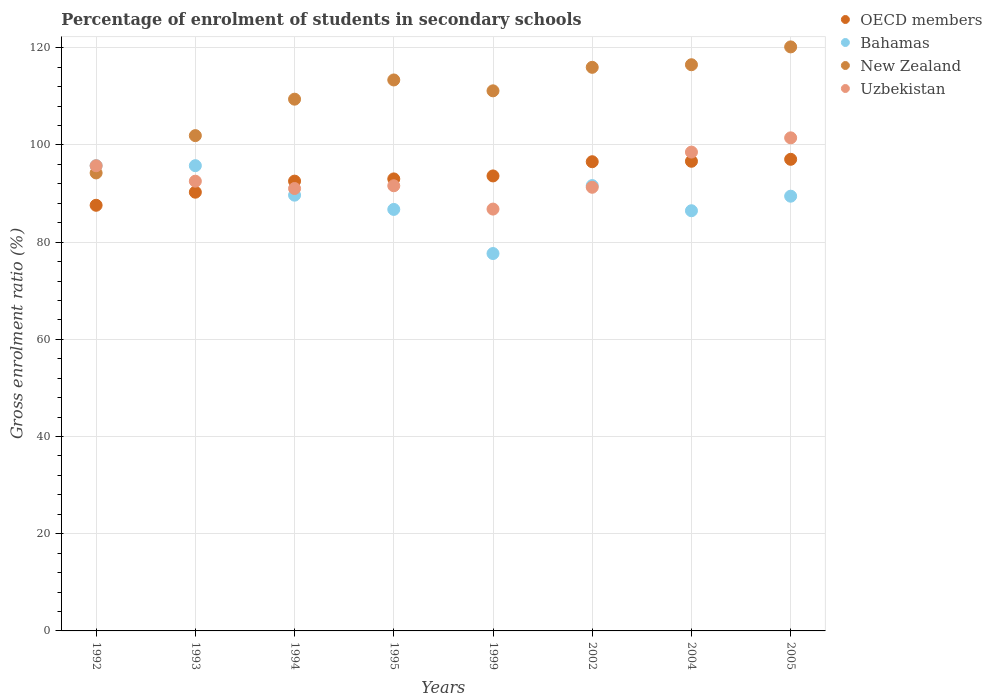How many different coloured dotlines are there?
Keep it short and to the point. 4. Is the number of dotlines equal to the number of legend labels?
Ensure brevity in your answer.  Yes. What is the percentage of students enrolled in secondary schools in OECD members in 2005?
Ensure brevity in your answer.  97.05. Across all years, what is the maximum percentage of students enrolled in secondary schools in Bahamas?
Offer a very short reply. 95.74. Across all years, what is the minimum percentage of students enrolled in secondary schools in Bahamas?
Provide a short and direct response. 77.66. What is the total percentage of students enrolled in secondary schools in Bahamas in the graph?
Keep it short and to the point. 713.09. What is the difference between the percentage of students enrolled in secondary schools in Uzbekistan in 1994 and that in 1999?
Your answer should be compact. 4.23. What is the difference between the percentage of students enrolled in secondary schools in New Zealand in 2004 and the percentage of students enrolled in secondary schools in Uzbekistan in 1994?
Keep it short and to the point. 25.47. What is the average percentage of students enrolled in secondary schools in Uzbekistan per year?
Your answer should be very brief. 93.62. In the year 1994, what is the difference between the percentage of students enrolled in secondary schools in Uzbekistan and percentage of students enrolled in secondary schools in Bahamas?
Provide a succinct answer. 1.37. In how many years, is the percentage of students enrolled in secondary schools in New Zealand greater than 4 %?
Your answer should be very brief. 8. What is the ratio of the percentage of students enrolled in secondary schools in Bahamas in 1994 to that in 1999?
Provide a succinct answer. 1.15. What is the difference between the highest and the second highest percentage of students enrolled in secondary schools in Uzbekistan?
Give a very brief answer. 2.93. What is the difference between the highest and the lowest percentage of students enrolled in secondary schools in Uzbekistan?
Your answer should be compact. 14.66. Is it the case that in every year, the sum of the percentage of students enrolled in secondary schools in Bahamas and percentage of students enrolled in secondary schools in New Zealand  is greater than the percentage of students enrolled in secondary schools in OECD members?
Your response must be concise. Yes. Does the percentage of students enrolled in secondary schools in OECD members monotonically increase over the years?
Your answer should be very brief. Yes. Is the percentage of students enrolled in secondary schools in Uzbekistan strictly greater than the percentage of students enrolled in secondary schools in Bahamas over the years?
Give a very brief answer. No. Is the percentage of students enrolled in secondary schools in OECD members strictly less than the percentage of students enrolled in secondary schools in Bahamas over the years?
Provide a short and direct response. No. How many dotlines are there?
Your answer should be very brief. 4. What is the difference between two consecutive major ticks on the Y-axis?
Make the answer very short. 20. Are the values on the major ticks of Y-axis written in scientific E-notation?
Your answer should be very brief. No. Does the graph contain any zero values?
Your answer should be compact. No. How are the legend labels stacked?
Your answer should be compact. Vertical. What is the title of the graph?
Offer a terse response. Percentage of enrolment of students in secondary schools. What is the label or title of the Y-axis?
Your answer should be compact. Gross enrolment ratio (%). What is the Gross enrolment ratio (%) of OECD members in 1992?
Ensure brevity in your answer.  87.59. What is the Gross enrolment ratio (%) of Bahamas in 1992?
Your answer should be compact. 95.73. What is the Gross enrolment ratio (%) of New Zealand in 1992?
Provide a succinct answer. 94.24. What is the Gross enrolment ratio (%) of Uzbekistan in 1992?
Offer a terse response. 95.72. What is the Gross enrolment ratio (%) in OECD members in 1993?
Ensure brevity in your answer.  90.28. What is the Gross enrolment ratio (%) in Bahamas in 1993?
Your response must be concise. 95.74. What is the Gross enrolment ratio (%) in New Zealand in 1993?
Provide a succinct answer. 101.92. What is the Gross enrolment ratio (%) of Uzbekistan in 1993?
Offer a terse response. 92.54. What is the Gross enrolment ratio (%) of OECD members in 1994?
Offer a terse response. 92.56. What is the Gross enrolment ratio (%) in Bahamas in 1994?
Provide a succinct answer. 89.67. What is the Gross enrolment ratio (%) in New Zealand in 1994?
Keep it short and to the point. 109.42. What is the Gross enrolment ratio (%) in Uzbekistan in 1994?
Offer a terse response. 91.03. What is the Gross enrolment ratio (%) of OECD members in 1995?
Ensure brevity in your answer.  93.01. What is the Gross enrolment ratio (%) in Bahamas in 1995?
Ensure brevity in your answer.  86.73. What is the Gross enrolment ratio (%) in New Zealand in 1995?
Your response must be concise. 113.37. What is the Gross enrolment ratio (%) of Uzbekistan in 1995?
Ensure brevity in your answer.  91.6. What is the Gross enrolment ratio (%) of OECD members in 1999?
Your answer should be very brief. 93.62. What is the Gross enrolment ratio (%) in Bahamas in 1999?
Provide a short and direct response. 77.66. What is the Gross enrolment ratio (%) in New Zealand in 1999?
Ensure brevity in your answer.  111.14. What is the Gross enrolment ratio (%) of Uzbekistan in 1999?
Ensure brevity in your answer.  86.8. What is the Gross enrolment ratio (%) of OECD members in 2002?
Ensure brevity in your answer.  96.55. What is the Gross enrolment ratio (%) in Bahamas in 2002?
Make the answer very short. 91.64. What is the Gross enrolment ratio (%) in New Zealand in 2002?
Offer a terse response. 115.97. What is the Gross enrolment ratio (%) in Uzbekistan in 2002?
Provide a short and direct response. 91.29. What is the Gross enrolment ratio (%) of OECD members in 2004?
Make the answer very short. 96.64. What is the Gross enrolment ratio (%) of Bahamas in 2004?
Make the answer very short. 86.46. What is the Gross enrolment ratio (%) of New Zealand in 2004?
Your answer should be very brief. 116.51. What is the Gross enrolment ratio (%) in Uzbekistan in 2004?
Give a very brief answer. 98.53. What is the Gross enrolment ratio (%) in OECD members in 2005?
Keep it short and to the point. 97.05. What is the Gross enrolment ratio (%) of Bahamas in 2005?
Your answer should be very brief. 89.46. What is the Gross enrolment ratio (%) of New Zealand in 2005?
Offer a very short reply. 120.18. What is the Gross enrolment ratio (%) in Uzbekistan in 2005?
Give a very brief answer. 101.46. Across all years, what is the maximum Gross enrolment ratio (%) of OECD members?
Your response must be concise. 97.05. Across all years, what is the maximum Gross enrolment ratio (%) in Bahamas?
Give a very brief answer. 95.74. Across all years, what is the maximum Gross enrolment ratio (%) in New Zealand?
Ensure brevity in your answer.  120.18. Across all years, what is the maximum Gross enrolment ratio (%) in Uzbekistan?
Provide a succinct answer. 101.46. Across all years, what is the minimum Gross enrolment ratio (%) in OECD members?
Your response must be concise. 87.59. Across all years, what is the minimum Gross enrolment ratio (%) in Bahamas?
Your answer should be very brief. 77.66. Across all years, what is the minimum Gross enrolment ratio (%) in New Zealand?
Provide a short and direct response. 94.24. Across all years, what is the minimum Gross enrolment ratio (%) of Uzbekistan?
Provide a short and direct response. 86.8. What is the total Gross enrolment ratio (%) of OECD members in the graph?
Give a very brief answer. 747.29. What is the total Gross enrolment ratio (%) in Bahamas in the graph?
Provide a short and direct response. 713.09. What is the total Gross enrolment ratio (%) in New Zealand in the graph?
Your response must be concise. 882.75. What is the total Gross enrolment ratio (%) of Uzbekistan in the graph?
Ensure brevity in your answer.  748.99. What is the difference between the Gross enrolment ratio (%) of OECD members in 1992 and that in 1993?
Provide a short and direct response. -2.69. What is the difference between the Gross enrolment ratio (%) of Bahamas in 1992 and that in 1993?
Provide a succinct answer. -0. What is the difference between the Gross enrolment ratio (%) of New Zealand in 1992 and that in 1993?
Your answer should be compact. -7.68. What is the difference between the Gross enrolment ratio (%) of Uzbekistan in 1992 and that in 1993?
Make the answer very short. 3.18. What is the difference between the Gross enrolment ratio (%) of OECD members in 1992 and that in 1994?
Ensure brevity in your answer.  -4.97. What is the difference between the Gross enrolment ratio (%) of Bahamas in 1992 and that in 1994?
Offer a very short reply. 6.07. What is the difference between the Gross enrolment ratio (%) in New Zealand in 1992 and that in 1994?
Ensure brevity in your answer.  -15.18. What is the difference between the Gross enrolment ratio (%) in Uzbekistan in 1992 and that in 1994?
Ensure brevity in your answer.  4.69. What is the difference between the Gross enrolment ratio (%) in OECD members in 1992 and that in 1995?
Your response must be concise. -5.43. What is the difference between the Gross enrolment ratio (%) of Bahamas in 1992 and that in 1995?
Offer a very short reply. 9. What is the difference between the Gross enrolment ratio (%) in New Zealand in 1992 and that in 1995?
Offer a very short reply. -19.13. What is the difference between the Gross enrolment ratio (%) of Uzbekistan in 1992 and that in 1995?
Give a very brief answer. 4.12. What is the difference between the Gross enrolment ratio (%) of OECD members in 1992 and that in 1999?
Provide a short and direct response. -6.04. What is the difference between the Gross enrolment ratio (%) of Bahamas in 1992 and that in 1999?
Offer a terse response. 18.08. What is the difference between the Gross enrolment ratio (%) of New Zealand in 1992 and that in 1999?
Offer a very short reply. -16.89. What is the difference between the Gross enrolment ratio (%) of Uzbekistan in 1992 and that in 1999?
Offer a terse response. 8.92. What is the difference between the Gross enrolment ratio (%) of OECD members in 1992 and that in 2002?
Provide a succinct answer. -8.96. What is the difference between the Gross enrolment ratio (%) of Bahamas in 1992 and that in 2002?
Ensure brevity in your answer.  4.1. What is the difference between the Gross enrolment ratio (%) of New Zealand in 1992 and that in 2002?
Give a very brief answer. -21.73. What is the difference between the Gross enrolment ratio (%) in Uzbekistan in 1992 and that in 2002?
Give a very brief answer. 4.43. What is the difference between the Gross enrolment ratio (%) in OECD members in 1992 and that in 2004?
Ensure brevity in your answer.  -9.05. What is the difference between the Gross enrolment ratio (%) of Bahamas in 1992 and that in 2004?
Your answer should be compact. 9.27. What is the difference between the Gross enrolment ratio (%) in New Zealand in 1992 and that in 2004?
Keep it short and to the point. -22.26. What is the difference between the Gross enrolment ratio (%) of Uzbekistan in 1992 and that in 2004?
Keep it short and to the point. -2.81. What is the difference between the Gross enrolment ratio (%) of OECD members in 1992 and that in 2005?
Provide a short and direct response. -9.46. What is the difference between the Gross enrolment ratio (%) of Bahamas in 1992 and that in 2005?
Provide a short and direct response. 6.28. What is the difference between the Gross enrolment ratio (%) of New Zealand in 1992 and that in 2005?
Offer a terse response. -25.93. What is the difference between the Gross enrolment ratio (%) in Uzbekistan in 1992 and that in 2005?
Make the answer very short. -5.74. What is the difference between the Gross enrolment ratio (%) of OECD members in 1993 and that in 1994?
Give a very brief answer. -2.28. What is the difference between the Gross enrolment ratio (%) in Bahamas in 1993 and that in 1994?
Make the answer very short. 6.07. What is the difference between the Gross enrolment ratio (%) in New Zealand in 1993 and that in 1994?
Make the answer very short. -7.5. What is the difference between the Gross enrolment ratio (%) of Uzbekistan in 1993 and that in 1994?
Offer a terse response. 1.51. What is the difference between the Gross enrolment ratio (%) in OECD members in 1993 and that in 1995?
Provide a short and direct response. -2.73. What is the difference between the Gross enrolment ratio (%) in Bahamas in 1993 and that in 1995?
Make the answer very short. 9. What is the difference between the Gross enrolment ratio (%) of New Zealand in 1993 and that in 1995?
Make the answer very short. -11.45. What is the difference between the Gross enrolment ratio (%) in Uzbekistan in 1993 and that in 1995?
Provide a succinct answer. 0.94. What is the difference between the Gross enrolment ratio (%) in OECD members in 1993 and that in 1999?
Your response must be concise. -3.35. What is the difference between the Gross enrolment ratio (%) of Bahamas in 1993 and that in 1999?
Your answer should be compact. 18.08. What is the difference between the Gross enrolment ratio (%) of New Zealand in 1993 and that in 1999?
Your answer should be compact. -9.22. What is the difference between the Gross enrolment ratio (%) in Uzbekistan in 1993 and that in 1999?
Offer a terse response. 5.74. What is the difference between the Gross enrolment ratio (%) of OECD members in 1993 and that in 2002?
Offer a terse response. -6.27. What is the difference between the Gross enrolment ratio (%) in Bahamas in 1993 and that in 2002?
Offer a terse response. 4.1. What is the difference between the Gross enrolment ratio (%) in New Zealand in 1993 and that in 2002?
Provide a short and direct response. -14.05. What is the difference between the Gross enrolment ratio (%) in Uzbekistan in 1993 and that in 2002?
Your answer should be compact. 1.25. What is the difference between the Gross enrolment ratio (%) in OECD members in 1993 and that in 2004?
Give a very brief answer. -6.36. What is the difference between the Gross enrolment ratio (%) in Bahamas in 1993 and that in 2004?
Give a very brief answer. 9.27. What is the difference between the Gross enrolment ratio (%) of New Zealand in 1993 and that in 2004?
Offer a terse response. -14.59. What is the difference between the Gross enrolment ratio (%) of Uzbekistan in 1993 and that in 2004?
Offer a very short reply. -5.99. What is the difference between the Gross enrolment ratio (%) in OECD members in 1993 and that in 2005?
Your response must be concise. -6.77. What is the difference between the Gross enrolment ratio (%) in Bahamas in 1993 and that in 2005?
Your response must be concise. 6.28. What is the difference between the Gross enrolment ratio (%) of New Zealand in 1993 and that in 2005?
Give a very brief answer. -18.26. What is the difference between the Gross enrolment ratio (%) in Uzbekistan in 1993 and that in 2005?
Provide a short and direct response. -8.92. What is the difference between the Gross enrolment ratio (%) of OECD members in 1994 and that in 1995?
Your answer should be compact. -0.46. What is the difference between the Gross enrolment ratio (%) in Bahamas in 1994 and that in 1995?
Offer a terse response. 2.93. What is the difference between the Gross enrolment ratio (%) in New Zealand in 1994 and that in 1995?
Offer a very short reply. -3.95. What is the difference between the Gross enrolment ratio (%) in Uzbekistan in 1994 and that in 1995?
Offer a terse response. -0.57. What is the difference between the Gross enrolment ratio (%) of OECD members in 1994 and that in 1999?
Provide a succinct answer. -1.07. What is the difference between the Gross enrolment ratio (%) of Bahamas in 1994 and that in 1999?
Provide a short and direct response. 12.01. What is the difference between the Gross enrolment ratio (%) of New Zealand in 1994 and that in 1999?
Offer a terse response. -1.72. What is the difference between the Gross enrolment ratio (%) in Uzbekistan in 1994 and that in 1999?
Ensure brevity in your answer.  4.23. What is the difference between the Gross enrolment ratio (%) in OECD members in 1994 and that in 2002?
Provide a short and direct response. -3.99. What is the difference between the Gross enrolment ratio (%) of Bahamas in 1994 and that in 2002?
Provide a succinct answer. -1.97. What is the difference between the Gross enrolment ratio (%) in New Zealand in 1994 and that in 2002?
Keep it short and to the point. -6.55. What is the difference between the Gross enrolment ratio (%) of Uzbekistan in 1994 and that in 2002?
Make the answer very short. -0.26. What is the difference between the Gross enrolment ratio (%) in OECD members in 1994 and that in 2004?
Ensure brevity in your answer.  -4.08. What is the difference between the Gross enrolment ratio (%) in Bahamas in 1994 and that in 2004?
Give a very brief answer. 3.2. What is the difference between the Gross enrolment ratio (%) of New Zealand in 1994 and that in 2004?
Make the answer very short. -7.08. What is the difference between the Gross enrolment ratio (%) in Uzbekistan in 1994 and that in 2004?
Your answer should be compact. -7.5. What is the difference between the Gross enrolment ratio (%) of OECD members in 1994 and that in 2005?
Give a very brief answer. -4.49. What is the difference between the Gross enrolment ratio (%) of Bahamas in 1994 and that in 2005?
Offer a very short reply. 0.21. What is the difference between the Gross enrolment ratio (%) in New Zealand in 1994 and that in 2005?
Offer a very short reply. -10.76. What is the difference between the Gross enrolment ratio (%) in Uzbekistan in 1994 and that in 2005?
Your answer should be very brief. -10.43. What is the difference between the Gross enrolment ratio (%) in OECD members in 1995 and that in 1999?
Your answer should be compact. -0.61. What is the difference between the Gross enrolment ratio (%) in Bahamas in 1995 and that in 1999?
Give a very brief answer. 9.08. What is the difference between the Gross enrolment ratio (%) in New Zealand in 1995 and that in 1999?
Provide a short and direct response. 2.24. What is the difference between the Gross enrolment ratio (%) of Uzbekistan in 1995 and that in 1999?
Provide a succinct answer. 4.8. What is the difference between the Gross enrolment ratio (%) of OECD members in 1995 and that in 2002?
Provide a succinct answer. -3.54. What is the difference between the Gross enrolment ratio (%) in Bahamas in 1995 and that in 2002?
Ensure brevity in your answer.  -4.9. What is the difference between the Gross enrolment ratio (%) in New Zealand in 1995 and that in 2002?
Ensure brevity in your answer.  -2.6. What is the difference between the Gross enrolment ratio (%) of Uzbekistan in 1995 and that in 2002?
Make the answer very short. 0.31. What is the difference between the Gross enrolment ratio (%) in OECD members in 1995 and that in 2004?
Offer a very short reply. -3.63. What is the difference between the Gross enrolment ratio (%) of Bahamas in 1995 and that in 2004?
Offer a terse response. 0.27. What is the difference between the Gross enrolment ratio (%) in New Zealand in 1995 and that in 2004?
Give a very brief answer. -3.13. What is the difference between the Gross enrolment ratio (%) of Uzbekistan in 1995 and that in 2004?
Provide a short and direct response. -6.93. What is the difference between the Gross enrolment ratio (%) in OECD members in 1995 and that in 2005?
Your answer should be compact. -4.03. What is the difference between the Gross enrolment ratio (%) in Bahamas in 1995 and that in 2005?
Your answer should be very brief. -2.72. What is the difference between the Gross enrolment ratio (%) in New Zealand in 1995 and that in 2005?
Your answer should be very brief. -6.8. What is the difference between the Gross enrolment ratio (%) of Uzbekistan in 1995 and that in 2005?
Make the answer very short. -9.86. What is the difference between the Gross enrolment ratio (%) of OECD members in 1999 and that in 2002?
Your answer should be compact. -2.93. What is the difference between the Gross enrolment ratio (%) in Bahamas in 1999 and that in 2002?
Your answer should be very brief. -13.98. What is the difference between the Gross enrolment ratio (%) in New Zealand in 1999 and that in 2002?
Provide a succinct answer. -4.84. What is the difference between the Gross enrolment ratio (%) in Uzbekistan in 1999 and that in 2002?
Your answer should be compact. -4.49. What is the difference between the Gross enrolment ratio (%) of OECD members in 1999 and that in 2004?
Make the answer very short. -3.02. What is the difference between the Gross enrolment ratio (%) in Bahamas in 1999 and that in 2004?
Provide a succinct answer. -8.81. What is the difference between the Gross enrolment ratio (%) of New Zealand in 1999 and that in 2004?
Provide a succinct answer. -5.37. What is the difference between the Gross enrolment ratio (%) in Uzbekistan in 1999 and that in 2004?
Offer a terse response. -11.73. What is the difference between the Gross enrolment ratio (%) of OECD members in 1999 and that in 2005?
Make the answer very short. -3.42. What is the difference between the Gross enrolment ratio (%) in Bahamas in 1999 and that in 2005?
Offer a terse response. -11.8. What is the difference between the Gross enrolment ratio (%) in New Zealand in 1999 and that in 2005?
Your response must be concise. -9.04. What is the difference between the Gross enrolment ratio (%) in Uzbekistan in 1999 and that in 2005?
Ensure brevity in your answer.  -14.66. What is the difference between the Gross enrolment ratio (%) in OECD members in 2002 and that in 2004?
Keep it short and to the point. -0.09. What is the difference between the Gross enrolment ratio (%) in Bahamas in 2002 and that in 2004?
Offer a very short reply. 5.17. What is the difference between the Gross enrolment ratio (%) in New Zealand in 2002 and that in 2004?
Your answer should be very brief. -0.53. What is the difference between the Gross enrolment ratio (%) in Uzbekistan in 2002 and that in 2004?
Ensure brevity in your answer.  -7.24. What is the difference between the Gross enrolment ratio (%) of OECD members in 2002 and that in 2005?
Offer a terse response. -0.5. What is the difference between the Gross enrolment ratio (%) of Bahamas in 2002 and that in 2005?
Give a very brief answer. 2.18. What is the difference between the Gross enrolment ratio (%) in New Zealand in 2002 and that in 2005?
Your answer should be very brief. -4.2. What is the difference between the Gross enrolment ratio (%) of Uzbekistan in 2002 and that in 2005?
Provide a short and direct response. -10.17. What is the difference between the Gross enrolment ratio (%) of OECD members in 2004 and that in 2005?
Give a very brief answer. -0.41. What is the difference between the Gross enrolment ratio (%) in Bahamas in 2004 and that in 2005?
Provide a short and direct response. -2.99. What is the difference between the Gross enrolment ratio (%) of New Zealand in 2004 and that in 2005?
Your answer should be compact. -3.67. What is the difference between the Gross enrolment ratio (%) of Uzbekistan in 2004 and that in 2005?
Offer a terse response. -2.93. What is the difference between the Gross enrolment ratio (%) of OECD members in 1992 and the Gross enrolment ratio (%) of Bahamas in 1993?
Give a very brief answer. -8.15. What is the difference between the Gross enrolment ratio (%) in OECD members in 1992 and the Gross enrolment ratio (%) in New Zealand in 1993?
Your answer should be compact. -14.33. What is the difference between the Gross enrolment ratio (%) of OECD members in 1992 and the Gross enrolment ratio (%) of Uzbekistan in 1993?
Offer a very short reply. -4.95. What is the difference between the Gross enrolment ratio (%) of Bahamas in 1992 and the Gross enrolment ratio (%) of New Zealand in 1993?
Make the answer very short. -6.19. What is the difference between the Gross enrolment ratio (%) in Bahamas in 1992 and the Gross enrolment ratio (%) in Uzbekistan in 1993?
Offer a terse response. 3.19. What is the difference between the Gross enrolment ratio (%) of New Zealand in 1992 and the Gross enrolment ratio (%) of Uzbekistan in 1993?
Your response must be concise. 1.7. What is the difference between the Gross enrolment ratio (%) in OECD members in 1992 and the Gross enrolment ratio (%) in Bahamas in 1994?
Your answer should be very brief. -2.08. What is the difference between the Gross enrolment ratio (%) of OECD members in 1992 and the Gross enrolment ratio (%) of New Zealand in 1994?
Give a very brief answer. -21.83. What is the difference between the Gross enrolment ratio (%) in OECD members in 1992 and the Gross enrolment ratio (%) in Uzbekistan in 1994?
Offer a very short reply. -3.45. What is the difference between the Gross enrolment ratio (%) in Bahamas in 1992 and the Gross enrolment ratio (%) in New Zealand in 1994?
Provide a succinct answer. -13.69. What is the difference between the Gross enrolment ratio (%) of Bahamas in 1992 and the Gross enrolment ratio (%) of Uzbekistan in 1994?
Make the answer very short. 4.7. What is the difference between the Gross enrolment ratio (%) of New Zealand in 1992 and the Gross enrolment ratio (%) of Uzbekistan in 1994?
Your response must be concise. 3.21. What is the difference between the Gross enrolment ratio (%) of OECD members in 1992 and the Gross enrolment ratio (%) of Bahamas in 1995?
Your answer should be very brief. 0.85. What is the difference between the Gross enrolment ratio (%) in OECD members in 1992 and the Gross enrolment ratio (%) in New Zealand in 1995?
Your answer should be compact. -25.79. What is the difference between the Gross enrolment ratio (%) in OECD members in 1992 and the Gross enrolment ratio (%) in Uzbekistan in 1995?
Your answer should be compact. -4.02. What is the difference between the Gross enrolment ratio (%) in Bahamas in 1992 and the Gross enrolment ratio (%) in New Zealand in 1995?
Your response must be concise. -17.64. What is the difference between the Gross enrolment ratio (%) of Bahamas in 1992 and the Gross enrolment ratio (%) of Uzbekistan in 1995?
Your answer should be compact. 4.13. What is the difference between the Gross enrolment ratio (%) in New Zealand in 1992 and the Gross enrolment ratio (%) in Uzbekistan in 1995?
Your answer should be very brief. 2.64. What is the difference between the Gross enrolment ratio (%) of OECD members in 1992 and the Gross enrolment ratio (%) of Bahamas in 1999?
Your answer should be compact. 9.93. What is the difference between the Gross enrolment ratio (%) in OECD members in 1992 and the Gross enrolment ratio (%) in New Zealand in 1999?
Your answer should be very brief. -23.55. What is the difference between the Gross enrolment ratio (%) in OECD members in 1992 and the Gross enrolment ratio (%) in Uzbekistan in 1999?
Make the answer very short. 0.78. What is the difference between the Gross enrolment ratio (%) of Bahamas in 1992 and the Gross enrolment ratio (%) of New Zealand in 1999?
Offer a very short reply. -15.4. What is the difference between the Gross enrolment ratio (%) in Bahamas in 1992 and the Gross enrolment ratio (%) in Uzbekistan in 1999?
Offer a terse response. 8.93. What is the difference between the Gross enrolment ratio (%) in New Zealand in 1992 and the Gross enrolment ratio (%) in Uzbekistan in 1999?
Offer a terse response. 7.44. What is the difference between the Gross enrolment ratio (%) in OECD members in 1992 and the Gross enrolment ratio (%) in Bahamas in 2002?
Offer a very short reply. -4.05. What is the difference between the Gross enrolment ratio (%) of OECD members in 1992 and the Gross enrolment ratio (%) of New Zealand in 2002?
Your answer should be very brief. -28.39. What is the difference between the Gross enrolment ratio (%) in OECD members in 1992 and the Gross enrolment ratio (%) in Uzbekistan in 2002?
Offer a terse response. -3.71. What is the difference between the Gross enrolment ratio (%) of Bahamas in 1992 and the Gross enrolment ratio (%) of New Zealand in 2002?
Keep it short and to the point. -20.24. What is the difference between the Gross enrolment ratio (%) in Bahamas in 1992 and the Gross enrolment ratio (%) in Uzbekistan in 2002?
Your answer should be compact. 4.44. What is the difference between the Gross enrolment ratio (%) in New Zealand in 1992 and the Gross enrolment ratio (%) in Uzbekistan in 2002?
Give a very brief answer. 2.95. What is the difference between the Gross enrolment ratio (%) in OECD members in 1992 and the Gross enrolment ratio (%) in Bahamas in 2004?
Offer a very short reply. 1.12. What is the difference between the Gross enrolment ratio (%) of OECD members in 1992 and the Gross enrolment ratio (%) of New Zealand in 2004?
Your answer should be very brief. -28.92. What is the difference between the Gross enrolment ratio (%) in OECD members in 1992 and the Gross enrolment ratio (%) in Uzbekistan in 2004?
Provide a short and direct response. -10.94. What is the difference between the Gross enrolment ratio (%) in Bahamas in 1992 and the Gross enrolment ratio (%) in New Zealand in 2004?
Make the answer very short. -20.77. What is the difference between the Gross enrolment ratio (%) in Bahamas in 1992 and the Gross enrolment ratio (%) in Uzbekistan in 2004?
Offer a very short reply. -2.8. What is the difference between the Gross enrolment ratio (%) of New Zealand in 1992 and the Gross enrolment ratio (%) of Uzbekistan in 2004?
Provide a succinct answer. -4.29. What is the difference between the Gross enrolment ratio (%) in OECD members in 1992 and the Gross enrolment ratio (%) in Bahamas in 2005?
Make the answer very short. -1.87. What is the difference between the Gross enrolment ratio (%) in OECD members in 1992 and the Gross enrolment ratio (%) in New Zealand in 2005?
Provide a short and direct response. -32.59. What is the difference between the Gross enrolment ratio (%) of OECD members in 1992 and the Gross enrolment ratio (%) of Uzbekistan in 2005?
Keep it short and to the point. -13.88. What is the difference between the Gross enrolment ratio (%) in Bahamas in 1992 and the Gross enrolment ratio (%) in New Zealand in 2005?
Provide a succinct answer. -24.44. What is the difference between the Gross enrolment ratio (%) of Bahamas in 1992 and the Gross enrolment ratio (%) of Uzbekistan in 2005?
Give a very brief answer. -5.73. What is the difference between the Gross enrolment ratio (%) in New Zealand in 1992 and the Gross enrolment ratio (%) in Uzbekistan in 2005?
Your answer should be compact. -7.22. What is the difference between the Gross enrolment ratio (%) in OECD members in 1993 and the Gross enrolment ratio (%) in Bahamas in 1994?
Make the answer very short. 0.61. What is the difference between the Gross enrolment ratio (%) of OECD members in 1993 and the Gross enrolment ratio (%) of New Zealand in 1994?
Your response must be concise. -19.14. What is the difference between the Gross enrolment ratio (%) of OECD members in 1993 and the Gross enrolment ratio (%) of Uzbekistan in 1994?
Your response must be concise. -0.76. What is the difference between the Gross enrolment ratio (%) in Bahamas in 1993 and the Gross enrolment ratio (%) in New Zealand in 1994?
Offer a terse response. -13.68. What is the difference between the Gross enrolment ratio (%) in Bahamas in 1993 and the Gross enrolment ratio (%) in Uzbekistan in 1994?
Offer a very short reply. 4.7. What is the difference between the Gross enrolment ratio (%) in New Zealand in 1993 and the Gross enrolment ratio (%) in Uzbekistan in 1994?
Make the answer very short. 10.89. What is the difference between the Gross enrolment ratio (%) of OECD members in 1993 and the Gross enrolment ratio (%) of Bahamas in 1995?
Your response must be concise. 3.54. What is the difference between the Gross enrolment ratio (%) of OECD members in 1993 and the Gross enrolment ratio (%) of New Zealand in 1995?
Make the answer very short. -23.1. What is the difference between the Gross enrolment ratio (%) of OECD members in 1993 and the Gross enrolment ratio (%) of Uzbekistan in 1995?
Ensure brevity in your answer.  -1.32. What is the difference between the Gross enrolment ratio (%) in Bahamas in 1993 and the Gross enrolment ratio (%) in New Zealand in 1995?
Provide a succinct answer. -17.64. What is the difference between the Gross enrolment ratio (%) in Bahamas in 1993 and the Gross enrolment ratio (%) in Uzbekistan in 1995?
Make the answer very short. 4.13. What is the difference between the Gross enrolment ratio (%) of New Zealand in 1993 and the Gross enrolment ratio (%) of Uzbekistan in 1995?
Make the answer very short. 10.32. What is the difference between the Gross enrolment ratio (%) of OECD members in 1993 and the Gross enrolment ratio (%) of Bahamas in 1999?
Provide a succinct answer. 12.62. What is the difference between the Gross enrolment ratio (%) of OECD members in 1993 and the Gross enrolment ratio (%) of New Zealand in 1999?
Your answer should be compact. -20.86. What is the difference between the Gross enrolment ratio (%) of OECD members in 1993 and the Gross enrolment ratio (%) of Uzbekistan in 1999?
Offer a terse response. 3.48. What is the difference between the Gross enrolment ratio (%) in Bahamas in 1993 and the Gross enrolment ratio (%) in New Zealand in 1999?
Ensure brevity in your answer.  -15.4. What is the difference between the Gross enrolment ratio (%) in Bahamas in 1993 and the Gross enrolment ratio (%) in Uzbekistan in 1999?
Ensure brevity in your answer.  8.93. What is the difference between the Gross enrolment ratio (%) in New Zealand in 1993 and the Gross enrolment ratio (%) in Uzbekistan in 1999?
Offer a terse response. 15.12. What is the difference between the Gross enrolment ratio (%) in OECD members in 1993 and the Gross enrolment ratio (%) in Bahamas in 2002?
Your response must be concise. -1.36. What is the difference between the Gross enrolment ratio (%) of OECD members in 1993 and the Gross enrolment ratio (%) of New Zealand in 2002?
Your response must be concise. -25.7. What is the difference between the Gross enrolment ratio (%) of OECD members in 1993 and the Gross enrolment ratio (%) of Uzbekistan in 2002?
Provide a short and direct response. -1.01. What is the difference between the Gross enrolment ratio (%) of Bahamas in 1993 and the Gross enrolment ratio (%) of New Zealand in 2002?
Offer a very short reply. -20.24. What is the difference between the Gross enrolment ratio (%) of Bahamas in 1993 and the Gross enrolment ratio (%) of Uzbekistan in 2002?
Your answer should be compact. 4.44. What is the difference between the Gross enrolment ratio (%) in New Zealand in 1993 and the Gross enrolment ratio (%) in Uzbekistan in 2002?
Ensure brevity in your answer.  10.63. What is the difference between the Gross enrolment ratio (%) of OECD members in 1993 and the Gross enrolment ratio (%) of Bahamas in 2004?
Provide a succinct answer. 3.82. What is the difference between the Gross enrolment ratio (%) of OECD members in 1993 and the Gross enrolment ratio (%) of New Zealand in 2004?
Offer a terse response. -26.23. What is the difference between the Gross enrolment ratio (%) of OECD members in 1993 and the Gross enrolment ratio (%) of Uzbekistan in 2004?
Make the answer very short. -8.25. What is the difference between the Gross enrolment ratio (%) in Bahamas in 1993 and the Gross enrolment ratio (%) in New Zealand in 2004?
Offer a very short reply. -20.77. What is the difference between the Gross enrolment ratio (%) in Bahamas in 1993 and the Gross enrolment ratio (%) in Uzbekistan in 2004?
Offer a terse response. -2.79. What is the difference between the Gross enrolment ratio (%) of New Zealand in 1993 and the Gross enrolment ratio (%) of Uzbekistan in 2004?
Offer a very short reply. 3.39. What is the difference between the Gross enrolment ratio (%) in OECD members in 1993 and the Gross enrolment ratio (%) in Bahamas in 2005?
Offer a terse response. 0.82. What is the difference between the Gross enrolment ratio (%) in OECD members in 1993 and the Gross enrolment ratio (%) in New Zealand in 2005?
Provide a succinct answer. -29.9. What is the difference between the Gross enrolment ratio (%) in OECD members in 1993 and the Gross enrolment ratio (%) in Uzbekistan in 2005?
Ensure brevity in your answer.  -11.19. What is the difference between the Gross enrolment ratio (%) in Bahamas in 1993 and the Gross enrolment ratio (%) in New Zealand in 2005?
Your answer should be compact. -24.44. What is the difference between the Gross enrolment ratio (%) in Bahamas in 1993 and the Gross enrolment ratio (%) in Uzbekistan in 2005?
Offer a terse response. -5.73. What is the difference between the Gross enrolment ratio (%) of New Zealand in 1993 and the Gross enrolment ratio (%) of Uzbekistan in 2005?
Your response must be concise. 0.46. What is the difference between the Gross enrolment ratio (%) in OECD members in 1994 and the Gross enrolment ratio (%) in Bahamas in 1995?
Offer a very short reply. 5.82. What is the difference between the Gross enrolment ratio (%) of OECD members in 1994 and the Gross enrolment ratio (%) of New Zealand in 1995?
Your answer should be very brief. -20.82. What is the difference between the Gross enrolment ratio (%) of OECD members in 1994 and the Gross enrolment ratio (%) of Uzbekistan in 1995?
Offer a very short reply. 0.95. What is the difference between the Gross enrolment ratio (%) in Bahamas in 1994 and the Gross enrolment ratio (%) in New Zealand in 1995?
Provide a short and direct response. -23.71. What is the difference between the Gross enrolment ratio (%) of Bahamas in 1994 and the Gross enrolment ratio (%) of Uzbekistan in 1995?
Offer a terse response. -1.94. What is the difference between the Gross enrolment ratio (%) in New Zealand in 1994 and the Gross enrolment ratio (%) in Uzbekistan in 1995?
Offer a very short reply. 17.82. What is the difference between the Gross enrolment ratio (%) of OECD members in 1994 and the Gross enrolment ratio (%) of Bahamas in 1999?
Make the answer very short. 14.9. What is the difference between the Gross enrolment ratio (%) of OECD members in 1994 and the Gross enrolment ratio (%) of New Zealand in 1999?
Your answer should be compact. -18.58. What is the difference between the Gross enrolment ratio (%) in OECD members in 1994 and the Gross enrolment ratio (%) in Uzbekistan in 1999?
Your answer should be compact. 5.75. What is the difference between the Gross enrolment ratio (%) of Bahamas in 1994 and the Gross enrolment ratio (%) of New Zealand in 1999?
Keep it short and to the point. -21.47. What is the difference between the Gross enrolment ratio (%) in Bahamas in 1994 and the Gross enrolment ratio (%) in Uzbekistan in 1999?
Provide a succinct answer. 2.86. What is the difference between the Gross enrolment ratio (%) of New Zealand in 1994 and the Gross enrolment ratio (%) of Uzbekistan in 1999?
Provide a succinct answer. 22.62. What is the difference between the Gross enrolment ratio (%) in OECD members in 1994 and the Gross enrolment ratio (%) in Bahamas in 2002?
Ensure brevity in your answer.  0.92. What is the difference between the Gross enrolment ratio (%) of OECD members in 1994 and the Gross enrolment ratio (%) of New Zealand in 2002?
Provide a succinct answer. -23.42. What is the difference between the Gross enrolment ratio (%) of OECD members in 1994 and the Gross enrolment ratio (%) of Uzbekistan in 2002?
Give a very brief answer. 1.26. What is the difference between the Gross enrolment ratio (%) of Bahamas in 1994 and the Gross enrolment ratio (%) of New Zealand in 2002?
Provide a short and direct response. -26.31. What is the difference between the Gross enrolment ratio (%) in Bahamas in 1994 and the Gross enrolment ratio (%) in Uzbekistan in 2002?
Keep it short and to the point. -1.62. What is the difference between the Gross enrolment ratio (%) in New Zealand in 1994 and the Gross enrolment ratio (%) in Uzbekistan in 2002?
Provide a short and direct response. 18.13. What is the difference between the Gross enrolment ratio (%) of OECD members in 1994 and the Gross enrolment ratio (%) of Bahamas in 2004?
Make the answer very short. 6.09. What is the difference between the Gross enrolment ratio (%) of OECD members in 1994 and the Gross enrolment ratio (%) of New Zealand in 2004?
Offer a very short reply. -23.95. What is the difference between the Gross enrolment ratio (%) in OECD members in 1994 and the Gross enrolment ratio (%) in Uzbekistan in 2004?
Your response must be concise. -5.98. What is the difference between the Gross enrolment ratio (%) of Bahamas in 1994 and the Gross enrolment ratio (%) of New Zealand in 2004?
Make the answer very short. -26.84. What is the difference between the Gross enrolment ratio (%) in Bahamas in 1994 and the Gross enrolment ratio (%) in Uzbekistan in 2004?
Ensure brevity in your answer.  -8.86. What is the difference between the Gross enrolment ratio (%) of New Zealand in 1994 and the Gross enrolment ratio (%) of Uzbekistan in 2004?
Make the answer very short. 10.89. What is the difference between the Gross enrolment ratio (%) of OECD members in 1994 and the Gross enrolment ratio (%) of Bahamas in 2005?
Provide a short and direct response. 3.1. What is the difference between the Gross enrolment ratio (%) of OECD members in 1994 and the Gross enrolment ratio (%) of New Zealand in 2005?
Your answer should be compact. -27.62. What is the difference between the Gross enrolment ratio (%) in OECD members in 1994 and the Gross enrolment ratio (%) in Uzbekistan in 2005?
Keep it short and to the point. -8.91. What is the difference between the Gross enrolment ratio (%) in Bahamas in 1994 and the Gross enrolment ratio (%) in New Zealand in 2005?
Make the answer very short. -30.51. What is the difference between the Gross enrolment ratio (%) of Bahamas in 1994 and the Gross enrolment ratio (%) of Uzbekistan in 2005?
Ensure brevity in your answer.  -11.8. What is the difference between the Gross enrolment ratio (%) of New Zealand in 1994 and the Gross enrolment ratio (%) of Uzbekistan in 2005?
Ensure brevity in your answer.  7.96. What is the difference between the Gross enrolment ratio (%) of OECD members in 1995 and the Gross enrolment ratio (%) of Bahamas in 1999?
Your answer should be very brief. 15.35. What is the difference between the Gross enrolment ratio (%) of OECD members in 1995 and the Gross enrolment ratio (%) of New Zealand in 1999?
Keep it short and to the point. -18.12. What is the difference between the Gross enrolment ratio (%) in OECD members in 1995 and the Gross enrolment ratio (%) in Uzbekistan in 1999?
Ensure brevity in your answer.  6.21. What is the difference between the Gross enrolment ratio (%) of Bahamas in 1995 and the Gross enrolment ratio (%) of New Zealand in 1999?
Your response must be concise. -24.4. What is the difference between the Gross enrolment ratio (%) in Bahamas in 1995 and the Gross enrolment ratio (%) in Uzbekistan in 1999?
Give a very brief answer. -0.07. What is the difference between the Gross enrolment ratio (%) in New Zealand in 1995 and the Gross enrolment ratio (%) in Uzbekistan in 1999?
Provide a succinct answer. 26.57. What is the difference between the Gross enrolment ratio (%) of OECD members in 1995 and the Gross enrolment ratio (%) of Bahamas in 2002?
Provide a short and direct response. 1.37. What is the difference between the Gross enrolment ratio (%) of OECD members in 1995 and the Gross enrolment ratio (%) of New Zealand in 2002?
Make the answer very short. -22.96. What is the difference between the Gross enrolment ratio (%) of OECD members in 1995 and the Gross enrolment ratio (%) of Uzbekistan in 2002?
Your answer should be compact. 1.72. What is the difference between the Gross enrolment ratio (%) in Bahamas in 1995 and the Gross enrolment ratio (%) in New Zealand in 2002?
Provide a succinct answer. -29.24. What is the difference between the Gross enrolment ratio (%) of Bahamas in 1995 and the Gross enrolment ratio (%) of Uzbekistan in 2002?
Give a very brief answer. -4.56. What is the difference between the Gross enrolment ratio (%) in New Zealand in 1995 and the Gross enrolment ratio (%) in Uzbekistan in 2002?
Your response must be concise. 22.08. What is the difference between the Gross enrolment ratio (%) in OECD members in 1995 and the Gross enrolment ratio (%) in Bahamas in 2004?
Offer a terse response. 6.55. What is the difference between the Gross enrolment ratio (%) in OECD members in 1995 and the Gross enrolment ratio (%) in New Zealand in 2004?
Your answer should be compact. -23.49. What is the difference between the Gross enrolment ratio (%) in OECD members in 1995 and the Gross enrolment ratio (%) in Uzbekistan in 2004?
Offer a terse response. -5.52. What is the difference between the Gross enrolment ratio (%) in Bahamas in 1995 and the Gross enrolment ratio (%) in New Zealand in 2004?
Provide a short and direct response. -29.77. What is the difference between the Gross enrolment ratio (%) of Bahamas in 1995 and the Gross enrolment ratio (%) of Uzbekistan in 2004?
Provide a short and direct response. -11.8. What is the difference between the Gross enrolment ratio (%) of New Zealand in 1995 and the Gross enrolment ratio (%) of Uzbekistan in 2004?
Offer a terse response. 14.84. What is the difference between the Gross enrolment ratio (%) of OECD members in 1995 and the Gross enrolment ratio (%) of Bahamas in 2005?
Offer a terse response. 3.56. What is the difference between the Gross enrolment ratio (%) of OECD members in 1995 and the Gross enrolment ratio (%) of New Zealand in 2005?
Provide a succinct answer. -27.16. What is the difference between the Gross enrolment ratio (%) in OECD members in 1995 and the Gross enrolment ratio (%) in Uzbekistan in 2005?
Your response must be concise. -8.45. What is the difference between the Gross enrolment ratio (%) of Bahamas in 1995 and the Gross enrolment ratio (%) of New Zealand in 2005?
Your answer should be very brief. -33.44. What is the difference between the Gross enrolment ratio (%) of Bahamas in 1995 and the Gross enrolment ratio (%) of Uzbekistan in 2005?
Provide a succinct answer. -14.73. What is the difference between the Gross enrolment ratio (%) of New Zealand in 1995 and the Gross enrolment ratio (%) of Uzbekistan in 2005?
Provide a succinct answer. 11.91. What is the difference between the Gross enrolment ratio (%) in OECD members in 1999 and the Gross enrolment ratio (%) in Bahamas in 2002?
Provide a short and direct response. 1.99. What is the difference between the Gross enrolment ratio (%) in OECD members in 1999 and the Gross enrolment ratio (%) in New Zealand in 2002?
Offer a very short reply. -22.35. What is the difference between the Gross enrolment ratio (%) of OECD members in 1999 and the Gross enrolment ratio (%) of Uzbekistan in 2002?
Provide a succinct answer. 2.33. What is the difference between the Gross enrolment ratio (%) of Bahamas in 1999 and the Gross enrolment ratio (%) of New Zealand in 2002?
Offer a terse response. -38.32. What is the difference between the Gross enrolment ratio (%) in Bahamas in 1999 and the Gross enrolment ratio (%) in Uzbekistan in 2002?
Provide a short and direct response. -13.63. What is the difference between the Gross enrolment ratio (%) of New Zealand in 1999 and the Gross enrolment ratio (%) of Uzbekistan in 2002?
Offer a very short reply. 19.85. What is the difference between the Gross enrolment ratio (%) in OECD members in 1999 and the Gross enrolment ratio (%) in Bahamas in 2004?
Give a very brief answer. 7.16. What is the difference between the Gross enrolment ratio (%) in OECD members in 1999 and the Gross enrolment ratio (%) in New Zealand in 2004?
Your answer should be compact. -22.88. What is the difference between the Gross enrolment ratio (%) of OECD members in 1999 and the Gross enrolment ratio (%) of Uzbekistan in 2004?
Provide a succinct answer. -4.91. What is the difference between the Gross enrolment ratio (%) in Bahamas in 1999 and the Gross enrolment ratio (%) in New Zealand in 2004?
Provide a succinct answer. -38.85. What is the difference between the Gross enrolment ratio (%) in Bahamas in 1999 and the Gross enrolment ratio (%) in Uzbekistan in 2004?
Provide a short and direct response. -20.87. What is the difference between the Gross enrolment ratio (%) of New Zealand in 1999 and the Gross enrolment ratio (%) of Uzbekistan in 2004?
Provide a succinct answer. 12.61. What is the difference between the Gross enrolment ratio (%) in OECD members in 1999 and the Gross enrolment ratio (%) in Bahamas in 2005?
Your answer should be compact. 4.17. What is the difference between the Gross enrolment ratio (%) in OECD members in 1999 and the Gross enrolment ratio (%) in New Zealand in 2005?
Give a very brief answer. -26.55. What is the difference between the Gross enrolment ratio (%) in OECD members in 1999 and the Gross enrolment ratio (%) in Uzbekistan in 2005?
Keep it short and to the point. -7.84. What is the difference between the Gross enrolment ratio (%) in Bahamas in 1999 and the Gross enrolment ratio (%) in New Zealand in 2005?
Your answer should be compact. -42.52. What is the difference between the Gross enrolment ratio (%) of Bahamas in 1999 and the Gross enrolment ratio (%) of Uzbekistan in 2005?
Provide a succinct answer. -23.81. What is the difference between the Gross enrolment ratio (%) of New Zealand in 1999 and the Gross enrolment ratio (%) of Uzbekistan in 2005?
Give a very brief answer. 9.67. What is the difference between the Gross enrolment ratio (%) in OECD members in 2002 and the Gross enrolment ratio (%) in Bahamas in 2004?
Provide a succinct answer. 10.09. What is the difference between the Gross enrolment ratio (%) in OECD members in 2002 and the Gross enrolment ratio (%) in New Zealand in 2004?
Offer a very short reply. -19.96. What is the difference between the Gross enrolment ratio (%) in OECD members in 2002 and the Gross enrolment ratio (%) in Uzbekistan in 2004?
Your response must be concise. -1.98. What is the difference between the Gross enrolment ratio (%) of Bahamas in 2002 and the Gross enrolment ratio (%) of New Zealand in 2004?
Make the answer very short. -24.87. What is the difference between the Gross enrolment ratio (%) in Bahamas in 2002 and the Gross enrolment ratio (%) in Uzbekistan in 2004?
Offer a very short reply. -6.89. What is the difference between the Gross enrolment ratio (%) in New Zealand in 2002 and the Gross enrolment ratio (%) in Uzbekistan in 2004?
Make the answer very short. 17.44. What is the difference between the Gross enrolment ratio (%) in OECD members in 2002 and the Gross enrolment ratio (%) in Bahamas in 2005?
Offer a terse response. 7.09. What is the difference between the Gross enrolment ratio (%) of OECD members in 2002 and the Gross enrolment ratio (%) of New Zealand in 2005?
Provide a succinct answer. -23.63. What is the difference between the Gross enrolment ratio (%) in OECD members in 2002 and the Gross enrolment ratio (%) in Uzbekistan in 2005?
Offer a terse response. -4.91. What is the difference between the Gross enrolment ratio (%) in Bahamas in 2002 and the Gross enrolment ratio (%) in New Zealand in 2005?
Provide a short and direct response. -28.54. What is the difference between the Gross enrolment ratio (%) of Bahamas in 2002 and the Gross enrolment ratio (%) of Uzbekistan in 2005?
Keep it short and to the point. -9.83. What is the difference between the Gross enrolment ratio (%) of New Zealand in 2002 and the Gross enrolment ratio (%) of Uzbekistan in 2005?
Your answer should be very brief. 14.51. What is the difference between the Gross enrolment ratio (%) of OECD members in 2004 and the Gross enrolment ratio (%) of Bahamas in 2005?
Offer a terse response. 7.18. What is the difference between the Gross enrolment ratio (%) of OECD members in 2004 and the Gross enrolment ratio (%) of New Zealand in 2005?
Keep it short and to the point. -23.54. What is the difference between the Gross enrolment ratio (%) in OECD members in 2004 and the Gross enrolment ratio (%) in Uzbekistan in 2005?
Provide a short and direct response. -4.82. What is the difference between the Gross enrolment ratio (%) in Bahamas in 2004 and the Gross enrolment ratio (%) in New Zealand in 2005?
Give a very brief answer. -33.71. What is the difference between the Gross enrolment ratio (%) in Bahamas in 2004 and the Gross enrolment ratio (%) in Uzbekistan in 2005?
Ensure brevity in your answer.  -15. What is the difference between the Gross enrolment ratio (%) of New Zealand in 2004 and the Gross enrolment ratio (%) of Uzbekistan in 2005?
Your answer should be very brief. 15.04. What is the average Gross enrolment ratio (%) in OECD members per year?
Make the answer very short. 93.41. What is the average Gross enrolment ratio (%) in Bahamas per year?
Provide a short and direct response. 89.14. What is the average Gross enrolment ratio (%) in New Zealand per year?
Offer a terse response. 110.34. What is the average Gross enrolment ratio (%) of Uzbekistan per year?
Offer a terse response. 93.62. In the year 1992, what is the difference between the Gross enrolment ratio (%) of OECD members and Gross enrolment ratio (%) of Bahamas?
Keep it short and to the point. -8.15. In the year 1992, what is the difference between the Gross enrolment ratio (%) of OECD members and Gross enrolment ratio (%) of New Zealand?
Make the answer very short. -6.66. In the year 1992, what is the difference between the Gross enrolment ratio (%) of OECD members and Gross enrolment ratio (%) of Uzbekistan?
Your response must be concise. -8.13. In the year 1992, what is the difference between the Gross enrolment ratio (%) of Bahamas and Gross enrolment ratio (%) of New Zealand?
Your response must be concise. 1.49. In the year 1992, what is the difference between the Gross enrolment ratio (%) in Bahamas and Gross enrolment ratio (%) in Uzbekistan?
Give a very brief answer. 0.01. In the year 1992, what is the difference between the Gross enrolment ratio (%) in New Zealand and Gross enrolment ratio (%) in Uzbekistan?
Your response must be concise. -1.48. In the year 1993, what is the difference between the Gross enrolment ratio (%) of OECD members and Gross enrolment ratio (%) of Bahamas?
Provide a succinct answer. -5.46. In the year 1993, what is the difference between the Gross enrolment ratio (%) of OECD members and Gross enrolment ratio (%) of New Zealand?
Provide a succinct answer. -11.64. In the year 1993, what is the difference between the Gross enrolment ratio (%) in OECD members and Gross enrolment ratio (%) in Uzbekistan?
Your response must be concise. -2.26. In the year 1993, what is the difference between the Gross enrolment ratio (%) in Bahamas and Gross enrolment ratio (%) in New Zealand?
Offer a very short reply. -6.18. In the year 1993, what is the difference between the Gross enrolment ratio (%) of Bahamas and Gross enrolment ratio (%) of Uzbekistan?
Your answer should be very brief. 3.2. In the year 1993, what is the difference between the Gross enrolment ratio (%) in New Zealand and Gross enrolment ratio (%) in Uzbekistan?
Your answer should be very brief. 9.38. In the year 1994, what is the difference between the Gross enrolment ratio (%) of OECD members and Gross enrolment ratio (%) of Bahamas?
Offer a very short reply. 2.89. In the year 1994, what is the difference between the Gross enrolment ratio (%) of OECD members and Gross enrolment ratio (%) of New Zealand?
Your answer should be compact. -16.86. In the year 1994, what is the difference between the Gross enrolment ratio (%) of OECD members and Gross enrolment ratio (%) of Uzbekistan?
Your answer should be very brief. 1.52. In the year 1994, what is the difference between the Gross enrolment ratio (%) in Bahamas and Gross enrolment ratio (%) in New Zealand?
Keep it short and to the point. -19.75. In the year 1994, what is the difference between the Gross enrolment ratio (%) of Bahamas and Gross enrolment ratio (%) of Uzbekistan?
Provide a succinct answer. -1.37. In the year 1994, what is the difference between the Gross enrolment ratio (%) of New Zealand and Gross enrolment ratio (%) of Uzbekistan?
Give a very brief answer. 18.39. In the year 1995, what is the difference between the Gross enrolment ratio (%) in OECD members and Gross enrolment ratio (%) in Bahamas?
Ensure brevity in your answer.  6.28. In the year 1995, what is the difference between the Gross enrolment ratio (%) of OECD members and Gross enrolment ratio (%) of New Zealand?
Your answer should be very brief. -20.36. In the year 1995, what is the difference between the Gross enrolment ratio (%) of OECD members and Gross enrolment ratio (%) of Uzbekistan?
Provide a succinct answer. 1.41. In the year 1995, what is the difference between the Gross enrolment ratio (%) of Bahamas and Gross enrolment ratio (%) of New Zealand?
Ensure brevity in your answer.  -26.64. In the year 1995, what is the difference between the Gross enrolment ratio (%) of Bahamas and Gross enrolment ratio (%) of Uzbekistan?
Your answer should be very brief. -4.87. In the year 1995, what is the difference between the Gross enrolment ratio (%) in New Zealand and Gross enrolment ratio (%) in Uzbekistan?
Ensure brevity in your answer.  21.77. In the year 1999, what is the difference between the Gross enrolment ratio (%) of OECD members and Gross enrolment ratio (%) of Bahamas?
Your answer should be compact. 15.97. In the year 1999, what is the difference between the Gross enrolment ratio (%) of OECD members and Gross enrolment ratio (%) of New Zealand?
Offer a terse response. -17.51. In the year 1999, what is the difference between the Gross enrolment ratio (%) of OECD members and Gross enrolment ratio (%) of Uzbekistan?
Ensure brevity in your answer.  6.82. In the year 1999, what is the difference between the Gross enrolment ratio (%) of Bahamas and Gross enrolment ratio (%) of New Zealand?
Give a very brief answer. -33.48. In the year 1999, what is the difference between the Gross enrolment ratio (%) of Bahamas and Gross enrolment ratio (%) of Uzbekistan?
Your response must be concise. -9.14. In the year 1999, what is the difference between the Gross enrolment ratio (%) of New Zealand and Gross enrolment ratio (%) of Uzbekistan?
Provide a succinct answer. 24.33. In the year 2002, what is the difference between the Gross enrolment ratio (%) in OECD members and Gross enrolment ratio (%) in Bahamas?
Offer a terse response. 4.91. In the year 2002, what is the difference between the Gross enrolment ratio (%) in OECD members and Gross enrolment ratio (%) in New Zealand?
Give a very brief answer. -19.42. In the year 2002, what is the difference between the Gross enrolment ratio (%) in OECD members and Gross enrolment ratio (%) in Uzbekistan?
Your answer should be compact. 5.26. In the year 2002, what is the difference between the Gross enrolment ratio (%) in Bahamas and Gross enrolment ratio (%) in New Zealand?
Provide a short and direct response. -24.34. In the year 2002, what is the difference between the Gross enrolment ratio (%) in Bahamas and Gross enrolment ratio (%) in Uzbekistan?
Offer a very short reply. 0.35. In the year 2002, what is the difference between the Gross enrolment ratio (%) in New Zealand and Gross enrolment ratio (%) in Uzbekistan?
Ensure brevity in your answer.  24.68. In the year 2004, what is the difference between the Gross enrolment ratio (%) of OECD members and Gross enrolment ratio (%) of Bahamas?
Your response must be concise. 10.18. In the year 2004, what is the difference between the Gross enrolment ratio (%) in OECD members and Gross enrolment ratio (%) in New Zealand?
Keep it short and to the point. -19.87. In the year 2004, what is the difference between the Gross enrolment ratio (%) of OECD members and Gross enrolment ratio (%) of Uzbekistan?
Make the answer very short. -1.89. In the year 2004, what is the difference between the Gross enrolment ratio (%) in Bahamas and Gross enrolment ratio (%) in New Zealand?
Your answer should be compact. -30.04. In the year 2004, what is the difference between the Gross enrolment ratio (%) in Bahamas and Gross enrolment ratio (%) in Uzbekistan?
Give a very brief answer. -12.07. In the year 2004, what is the difference between the Gross enrolment ratio (%) in New Zealand and Gross enrolment ratio (%) in Uzbekistan?
Provide a succinct answer. 17.97. In the year 2005, what is the difference between the Gross enrolment ratio (%) in OECD members and Gross enrolment ratio (%) in Bahamas?
Provide a short and direct response. 7.59. In the year 2005, what is the difference between the Gross enrolment ratio (%) of OECD members and Gross enrolment ratio (%) of New Zealand?
Give a very brief answer. -23.13. In the year 2005, what is the difference between the Gross enrolment ratio (%) in OECD members and Gross enrolment ratio (%) in Uzbekistan?
Offer a terse response. -4.42. In the year 2005, what is the difference between the Gross enrolment ratio (%) in Bahamas and Gross enrolment ratio (%) in New Zealand?
Offer a terse response. -30.72. In the year 2005, what is the difference between the Gross enrolment ratio (%) of Bahamas and Gross enrolment ratio (%) of Uzbekistan?
Offer a very short reply. -12.01. In the year 2005, what is the difference between the Gross enrolment ratio (%) in New Zealand and Gross enrolment ratio (%) in Uzbekistan?
Keep it short and to the point. 18.71. What is the ratio of the Gross enrolment ratio (%) of OECD members in 1992 to that in 1993?
Keep it short and to the point. 0.97. What is the ratio of the Gross enrolment ratio (%) of New Zealand in 1992 to that in 1993?
Provide a short and direct response. 0.92. What is the ratio of the Gross enrolment ratio (%) in Uzbekistan in 1992 to that in 1993?
Your answer should be very brief. 1.03. What is the ratio of the Gross enrolment ratio (%) of OECD members in 1992 to that in 1994?
Your answer should be compact. 0.95. What is the ratio of the Gross enrolment ratio (%) in Bahamas in 1992 to that in 1994?
Make the answer very short. 1.07. What is the ratio of the Gross enrolment ratio (%) of New Zealand in 1992 to that in 1994?
Your answer should be compact. 0.86. What is the ratio of the Gross enrolment ratio (%) of Uzbekistan in 1992 to that in 1994?
Your answer should be compact. 1.05. What is the ratio of the Gross enrolment ratio (%) of OECD members in 1992 to that in 1995?
Offer a terse response. 0.94. What is the ratio of the Gross enrolment ratio (%) of Bahamas in 1992 to that in 1995?
Your answer should be very brief. 1.1. What is the ratio of the Gross enrolment ratio (%) in New Zealand in 1992 to that in 1995?
Offer a very short reply. 0.83. What is the ratio of the Gross enrolment ratio (%) in Uzbekistan in 1992 to that in 1995?
Make the answer very short. 1.04. What is the ratio of the Gross enrolment ratio (%) in OECD members in 1992 to that in 1999?
Ensure brevity in your answer.  0.94. What is the ratio of the Gross enrolment ratio (%) in Bahamas in 1992 to that in 1999?
Offer a very short reply. 1.23. What is the ratio of the Gross enrolment ratio (%) of New Zealand in 1992 to that in 1999?
Offer a very short reply. 0.85. What is the ratio of the Gross enrolment ratio (%) of Uzbekistan in 1992 to that in 1999?
Ensure brevity in your answer.  1.1. What is the ratio of the Gross enrolment ratio (%) in OECD members in 1992 to that in 2002?
Give a very brief answer. 0.91. What is the ratio of the Gross enrolment ratio (%) in Bahamas in 1992 to that in 2002?
Offer a terse response. 1.04. What is the ratio of the Gross enrolment ratio (%) in New Zealand in 1992 to that in 2002?
Offer a terse response. 0.81. What is the ratio of the Gross enrolment ratio (%) in Uzbekistan in 1992 to that in 2002?
Your answer should be compact. 1.05. What is the ratio of the Gross enrolment ratio (%) in OECD members in 1992 to that in 2004?
Provide a succinct answer. 0.91. What is the ratio of the Gross enrolment ratio (%) of Bahamas in 1992 to that in 2004?
Ensure brevity in your answer.  1.11. What is the ratio of the Gross enrolment ratio (%) in New Zealand in 1992 to that in 2004?
Give a very brief answer. 0.81. What is the ratio of the Gross enrolment ratio (%) in Uzbekistan in 1992 to that in 2004?
Your response must be concise. 0.97. What is the ratio of the Gross enrolment ratio (%) in OECD members in 1992 to that in 2005?
Provide a short and direct response. 0.9. What is the ratio of the Gross enrolment ratio (%) in Bahamas in 1992 to that in 2005?
Offer a terse response. 1.07. What is the ratio of the Gross enrolment ratio (%) of New Zealand in 1992 to that in 2005?
Ensure brevity in your answer.  0.78. What is the ratio of the Gross enrolment ratio (%) in Uzbekistan in 1992 to that in 2005?
Ensure brevity in your answer.  0.94. What is the ratio of the Gross enrolment ratio (%) of OECD members in 1993 to that in 1994?
Offer a terse response. 0.98. What is the ratio of the Gross enrolment ratio (%) of Bahamas in 1993 to that in 1994?
Offer a very short reply. 1.07. What is the ratio of the Gross enrolment ratio (%) in New Zealand in 1993 to that in 1994?
Your response must be concise. 0.93. What is the ratio of the Gross enrolment ratio (%) of Uzbekistan in 1993 to that in 1994?
Your answer should be very brief. 1.02. What is the ratio of the Gross enrolment ratio (%) in OECD members in 1993 to that in 1995?
Provide a short and direct response. 0.97. What is the ratio of the Gross enrolment ratio (%) of Bahamas in 1993 to that in 1995?
Your answer should be compact. 1.1. What is the ratio of the Gross enrolment ratio (%) of New Zealand in 1993 to that in 1995?
Your answer should be very brief. 0.9. What is the ratio of the Gross enrolment ratio (%) of Uzbekistan in 1993 to that in 1995?
Your response must be concise. 1.01. What is the ratio of the Gross enrolment ratio (%) of Bahamas in 1993 to that in 1999?
Keep it short and to the point. 1.23. What is the ratio of the Gross enrolment ratio (%) of New Zealand in 1993 to that in 1999?
Provide a succinct answer. 0.92. What is the ratio of the Gross enrolment ratio (%) of Uzbekistan in 1993 to that in 1999?
Give a very brief answer. 1.07. What is the ratio of the Gross enrolment ratio (%) in OECD members in 1993 to that in 2002?
Ensure brevity in your answer.  0.94. What is the ratio of the Gross enrolment ratio (%) in Bahamas in 1993 to that in 2002?
Offer a terse response. 1.04. What is the ratio of the Gross enrolment ratio (%) in New Zealand in 1993 to that in 2002?
Your answer should be compact. 0.88. What is the ratio of the Gross enrolment ratio (%) in Uzbekistan in 1993 to that in 2002?
Give a very brief answer. 1.01. What is the ratio of the Gross enrolment ratio (%) of OECD members in 1993 to that in 2004?
Your response must be concise. 0.93. What is the ratio of the Gross enrolment ratio (%) of Bahamas in 1993 to that in 2004?
Your response must be concise. 1.11. What is the ratio of the Gross enrolment ratio (%) in New Zealand in 1993 to that in 2004?
Ensure brevity in your answer.  0.87. What is the ratio of the Gross enrolment ratio (%) of Uzbekistan in 1993 to that in 2004?
Provide a succinct answer. 0.94. What is the ratio of the Gross enrolment ratio (%) of OECD members in 1993 to that in 2005?
Provide a succinct answer. 0.93. What is the ratio of the Gross enrolment ratio (%) of Bahamas in 1993 to that in 2005?
Your response must be concise. 1.07. What is the ratio of the Gross enrolment ratio (%) of New Zealand in 1993 to that in 2005?
Offer a very short reply. 0.85. What is the ratio of the Gross enrolment ratio (%) in Uzbekistan in 1993 to that in 2005?
Offer a terse response. 0.91. What is the ratio of the Gross enrolment ratio (%) of Bahamas in 1994 to that in 1995?
Your response must be concise. 1.03. What is the ratio of the Gross enrolment ratio (%) in New Zealand in 1994 to that in 1995?
Ensure brevity in your answer.  0.97. What is the ratio of the Gross enrolment ratio (%) in Bahamas in 1994 to that in 1999?
Your answer should be compact. 1.15. What is the ratio of the Gross enrolment ratio (%) of New Zealand in 1994 to that in 1999?
Your answer should be compact. 0.98. What is the ratio of the Gross enrolment ratio (%) of Uzbekistan in 1994 to that in 1999?
Your answer should be compact. 1.05. What is the ratio of the Gross enrolment ratio (%) in OECD members in 1994 to that in 2002?
Your response must be concise. 0.96. What is the ratio of the Gross enrolment ratio (%) of Bahamas in 1994 to that in 2002?
Offer a very short reply. 0.98. What is the ratio of the Gross enrolment ratio (%) of New Zealand in 1994 to that in 2002?
Your response must be concise. 0.94. What is the ratio of the Gross enrolment ratio (%) of Uzbekistan in 1994 to that in 2002?
Give a very brief answer. 1. What is the ratio of the Gross enrolment ratio (%) in OECD members in 1994 to that in 2004?
Offer a terse response. 0.96. What is the ratio of the Gross enrolment ratio (%) of Bahamas in 1994 to that in 2004?
Your response must be concise. 1.04. What is the ratio of the Gross enrolment ratio (%) of New Zealand in 1994 to that in 2004?
Keep it short and to the point. 0.94. What is the ratio of the Gross enrolment ratio (%) in Uzbekistan in 1994 to that in 2004?
Your response must be concise. 0.92. What is the ratio of the Gross enrolment ratio (%) of OECD members in 1994 to that in 2005?
Offer a terse response. 0.95. What is the ratio of the Gross enrolment ratio (%) in Bahamas in 1994 to that in 2005?
Your response must be concise. 1. What is the ratio of the Gross enrolment ratio (%) in New Zealand in 1994 to that in 2005?
Offer a very short reply. 0.91. What is the ratio of the Gross enrolment ratio (%) of Uzbekistan in 1994 to that in 2005?
Provide a succinct answer. 0.9. What is the ratio of the Gross enrolment ratio (%) of Bahamas in 1995 to that in 1999?
Keep it short and to the point. 1.12. What is the ratio of the Gross enrolment ratio (%) in New Zealand in 1995 to that in 1999?
Give a very brief answer. 1.02. What is the ratio of the Gross enrolment ratio (%) of Uzbekistan in 1995 to that in 1999?
Offer a terse response. 1.06. What is the ratio of the Gross enrolment ratio (%) in OECD members in 1995 to that in 2002?
Provide a succinct answer. 0.96. What is the ratio of the Gross enrolment ratio (%) of Bahamas in 1995 to that in 2002?
Give a very brief answer. 0.95. What is the ratio of the Gross enrolment ratio (%) of New Zealand in 1995 to that in 2002?
Make the answer very short. 0.98. What is the ratio of the Gross enrolment ratio (%) in OECD members in 1995 to that in 2004?
Provide a succinct answer. 0.96. What is the ratio of the Gross enrolment ratio (%) of New Zealand in 1995 to that in 2004?
Keep it short and to the point. 0.97. What is the ratio of the Gross enrolment ratio (%) of Uzbekistan in 1995 to that in 2004?
Provide a succinct answer. 0.93. What is the ratio of the Gross enrolment ratio (%) in OECD members in 1995 to that in 2005?
Give a very brief answer. 0.96. What is the ratio of the Gross enrolment ratio (%) of Bahamas in 1995 to that in 2005?
Your answer should be compact. 0.97. What is the ratio of the Gross enrolment ratio (%) in New Zealand in 1995 to that in 2005?
Offer a terse response. 0.94. What is the ratio of the Gross enrolment ratio (%) in Uzbekistan in 1995 to that in 2005?
Your answer should be very brief. 0.9. What is the ratio of the Gross enrolment ratio (%) of OECD members in 1999 to that in 2002?
Keep it short and to the point. 0.97. What is the ratio of the Gross enrolment ratio (%) of Bahamas in 1999 to that in 2002?
Keep it short and to the point. 0.85. What is the ratio of the Gross enrolment ratio (%) in New Zealand in 1999 to that in 2002?
Your answer should be compact. 0.96. What is the ratio of the Gross enrolment ratio (%) of Uzbekistan in 1999 to that in 2002?
Your answer should be very brief. 0.95. What is the ratio of the Gross enrolment ratio (%) in OECD members in 1999 to that in 2004?
Your answer should be very brief. 0.97. What is the ratio of the Gross enrolment ratio (%) of Bahamas in 1999 to that in 2004?
Your answer should be compact. 0.9. What is the ratio of the Gross enrolment ratio (%) in New Zealand in 1999 to that in 2004?
Your answer should be very brief. 0.95. What is the ratio of the Gross enrolment ratio (%) in Uzbekistan in 1999 to that in 2004?
Provide a succinct answer. 0.88. What is the ratio of the Gross enrolment ratio (%) of OECD members in 1999 to that in 2005?
Ensure brevity in your answer.  0.96. What is the ratio of the Gross enrolment ratio (%) in Bahamas in 1999 to that in 2005?
Give a very brief answer. 0.87. What is the ratio of the Gross enrolment ratio (%) of New Zealand in 1999 to that in 2005?
Offer a terse response. 0.92. What is the ratio of the Gross enrolment ratio (%) in Uzbekistan in 1999 to that in 2005?
Your answer should be compact. 0.86. What is the ratio of the Gross enrolment ratio (%) in OECD members in 2002 to that in 2004?
Keep it short and to the point. 1. What is the ratio of the Gross enrolment ratio (%) of Bahamas in 2002 to that in 2004?
Your response must be concise. 1.06. What is the ratio of the Gross enrolment ratio (%) in New Zealand in 2002 to that in 2004?
Offer a terse response. 1. What is the ratio of the Gross enrolment ratio (%) of Uzbekistan in 2002 to that in 2004?
Make the answer very short. 0.93. What is the ratio of the Gross enrolment ratio (%) in OECD members in 2002 to that in 2005?
Make the answer very short. 0.99. What is the ratio of the Gross enrolment ratio (%) in Bahamas in 2002 to that in 2005?
Give a very brief answer. 1.02. What is the ratio of the Gross enrolment ratio (%) of New Zealand in 2002 to that in 2005?
Provide a short and direct response. 0.96. What is the ratio of the Gross enrolment ratio (%) in Uzbekistan in 2002 to that in 2005?
Make the answer very short. 0.9. What is the ratio of the Gross enrolment ratio (%) of OECD members in 2004 to that in 2005?
Offer a very short reply. 1. What is the ratio of the Gross enrolment ratio (%) in Bahamas in 2004 to that in 2005?
Offer a terse response. 0.97. What is the ratio of the Gross enrolment ratio (%) of New Zealand in 2004 to that in 2005?
Ensure brevity in your answer.  0.97. What is the ratio of the Gross enrolment ratio (%) of Uzbekistan in 2004 to that in 2005?
Give a very brief answer. 0.97. What is the difference between the highest and the second highest Gross enrolment ratio (%) of OECD members?
Provide a short and direct response. 0.41. What is the difference between the highest and the second highest Gross enrolment ratio (%) of Bahamas?
Provide a succinct answer. 0. What is the difference between the highest and the second highest Gross enrolment ratio (%) in New Zealand?
Keep it short and to the point. 3.67. What is the difference between the highest and the second highest Gross enrolment ratio (%) in Uzbekistan?
Provide a short and direct response. 2.93. What is the difference between the highest and the lowest Gross enrolment ratio (%) of OECD members?
Provide a succinct answer. 9.46. What is the difference between the highest and the lowest Gross enrolment ratio (%) in Bahamas?
Keep it short and to the point. 18.08. What is the difference between the highest and the lowest Gross enrolment ratio (%) of New Zealand?
Your answer should be compact. 25.93. What is the difference between the highest and the lowest Gross enrolment ratio (%) of Uzbekistan?
Offer a terse response. 14.66. 